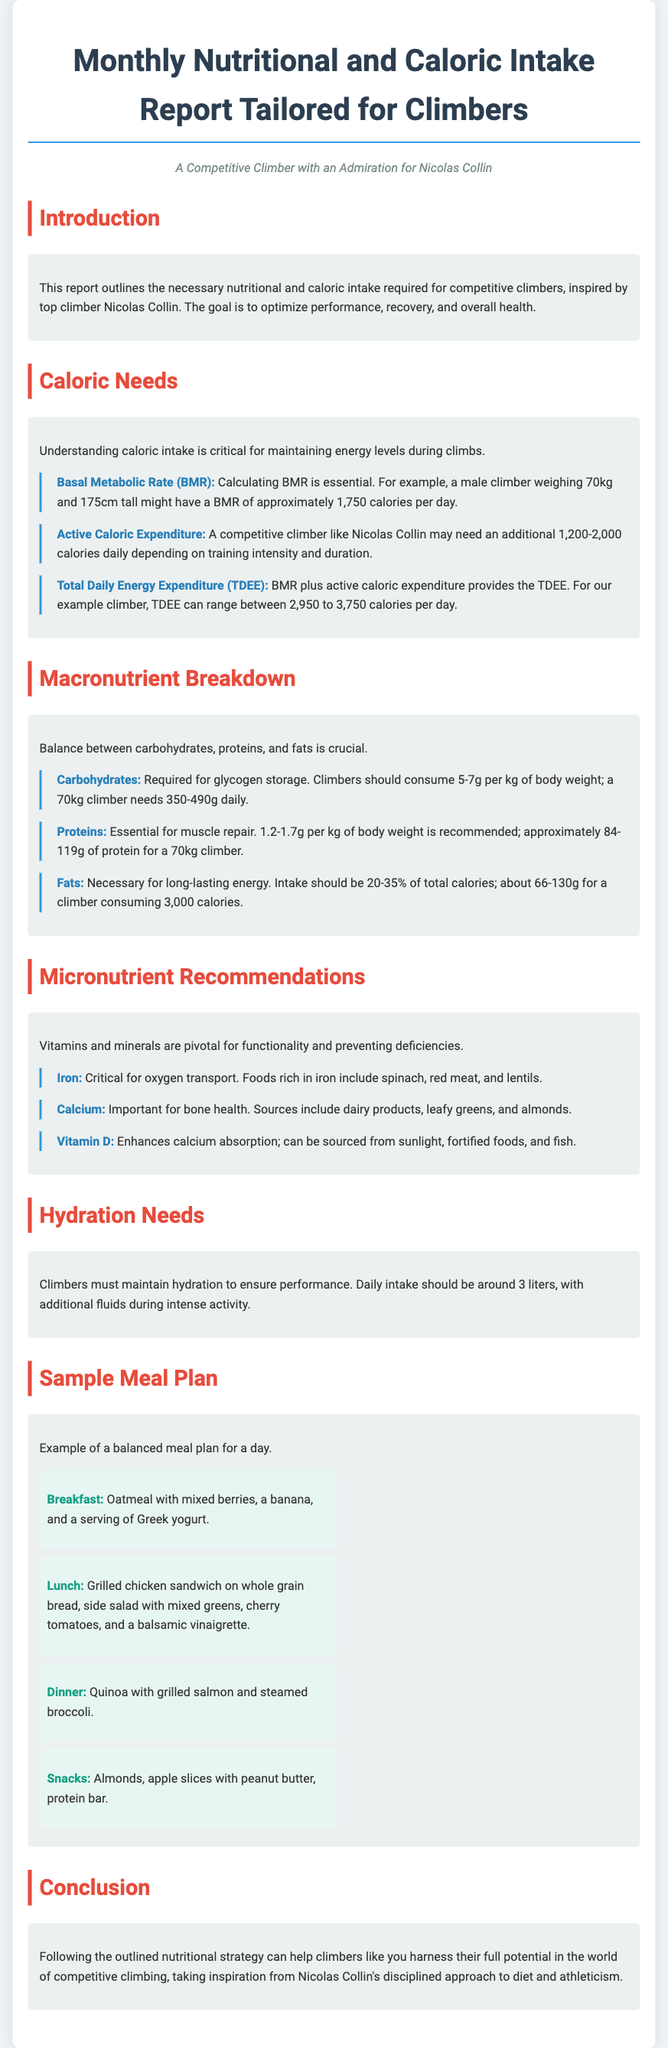What is the title of the report? The title of the report is stated at the top of the document.
Answer: Monthly Nutritional and Caloric Intake Report Tailored for Climbers What is the estimated BMR for a 70kg male climber? The BMR is calculated based on the example given in the report.
Answer: 1,750 calories per day What is the daily carbohydrate intake recommended for a 70kg climber? The daily intake is specified in the Macronutrient Breakdown section.
Answer: 350-490g What should be the daily hydration intake for climbers? The hydration needs are specified in a dedicated section.
Answer: Around 3 liters How much protein is recommended for a 70kg climber? The protein requirement is mentioned alongside the recommended intake per kg body weight.
Answer: 84-119g What is included in the sample breakfast? The breakfast details are listed in the Sample Meal Plan section.
Answer: Oatmeal with mixed berries, a banana, and a serving of Greek yogurt Which mineral is critical for oxygen transport? The micronutrient recommendations detail various essential vitamins and minerals.
Answer: Iron What is the purpose of the report? The introduction outlines the main goal of the report.
Answer: Optimize performance, recovery, and overall health What type of meal is suggested for lunch? The meal plan explicitly states the lunch options provided.
Answer: Grilled chicken sandwich on whole grain bread, side salad with mixed greens, cherry tomatoes, and a balsamic vinaigrette 